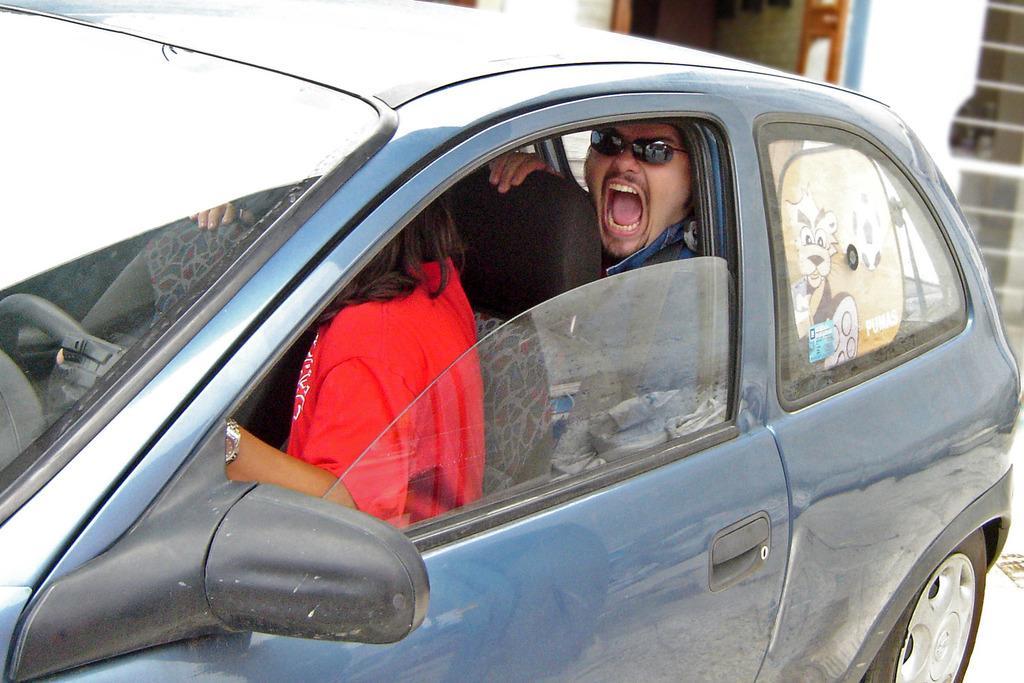Could you give a brief overview of what you see in this image? In this image,there is a car. The color of the car is blue. A woman is sitting in the front seat. She wears red color dress. A man at the back seat is shouting. He wears goggles. 